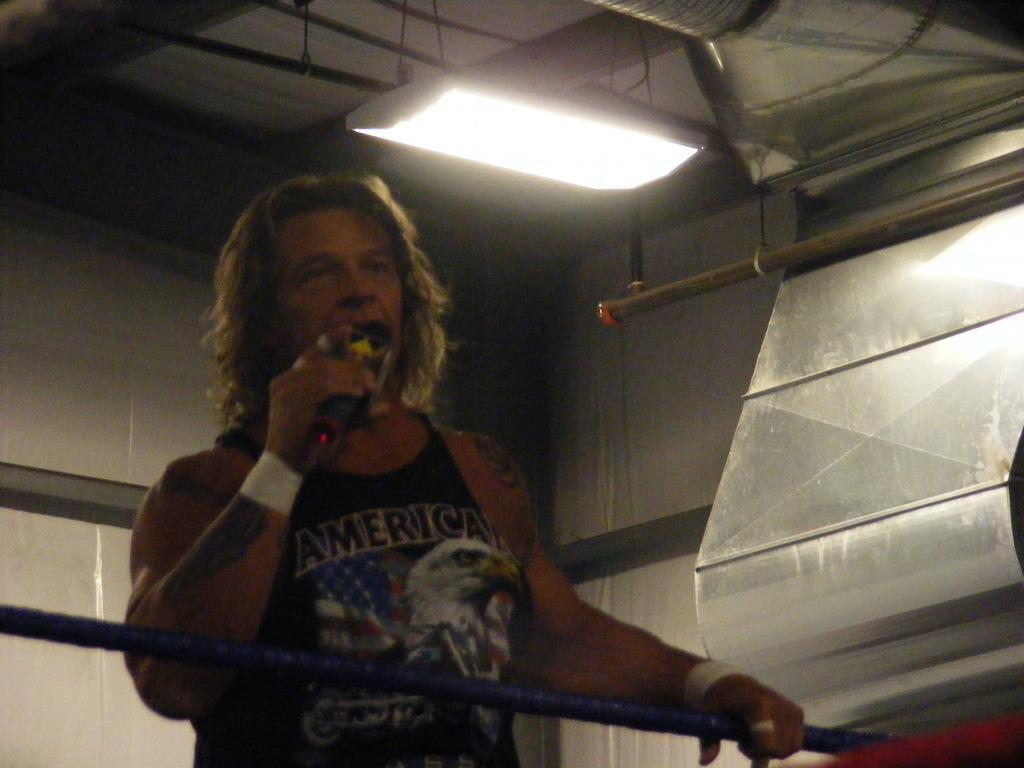Please provide a concise description of this image. In this picture there is a man , holding a mic in his hand and talking and holding a ring post. In the background there is air conditioned and also light is attached to the roof. 